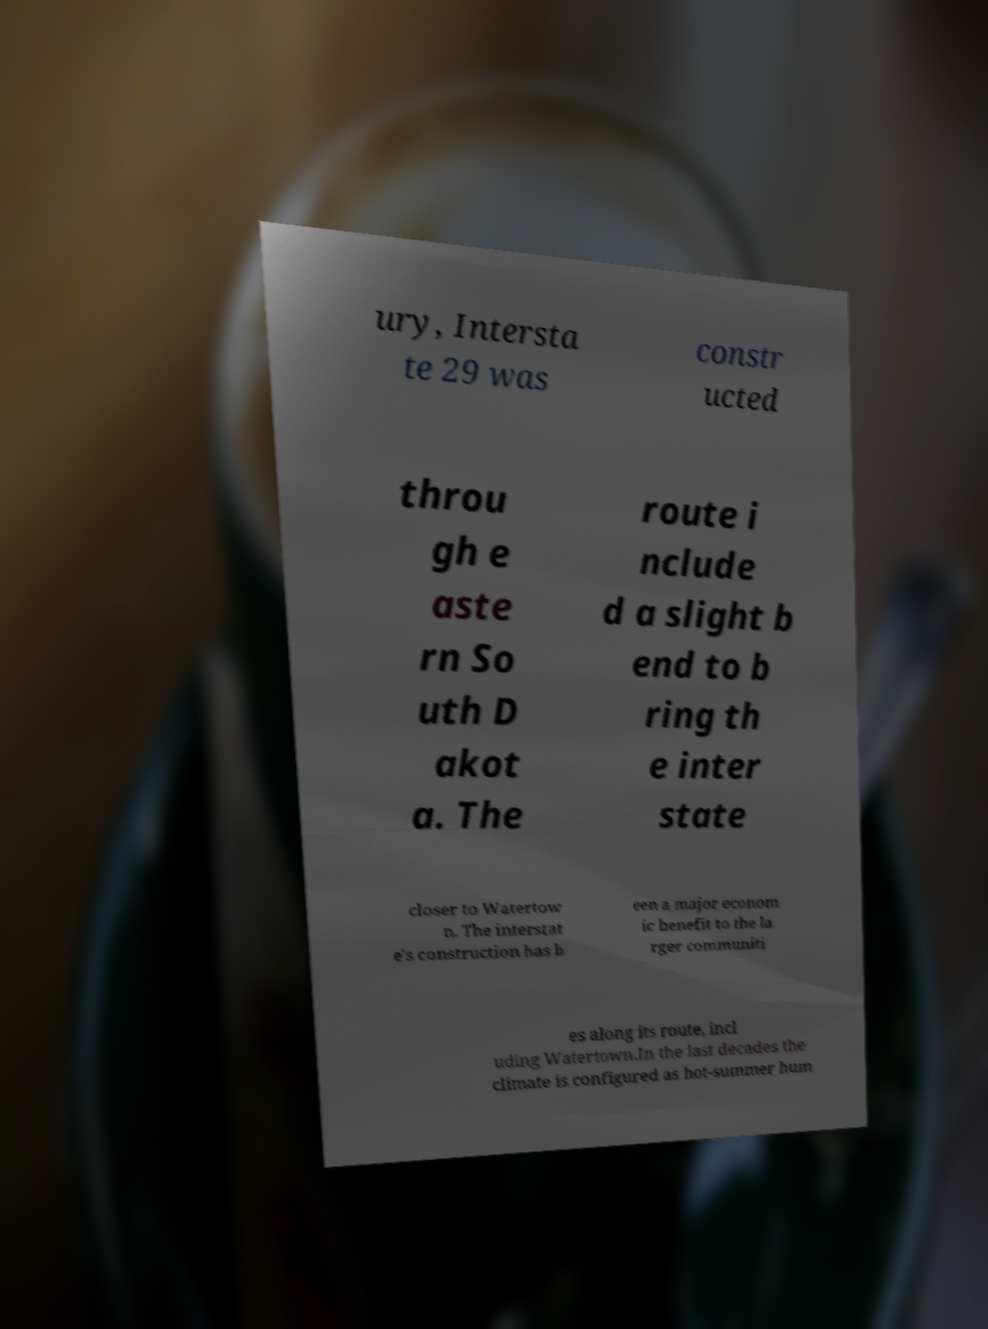What messages or text are displayed in this image? I need them in a readable, typed format. ury, Intersta te 29 was constr ucted throu gh e aste rn So uth D akot a. The route i nclude d a slight b end to b ring th e inter state closer to Watertow n. The interstat e's construction has b een a major econom ic benefit to the la rger communiti es along its route, incl uding Watertown.In the last decades the climate is configured as hot-summer hum 